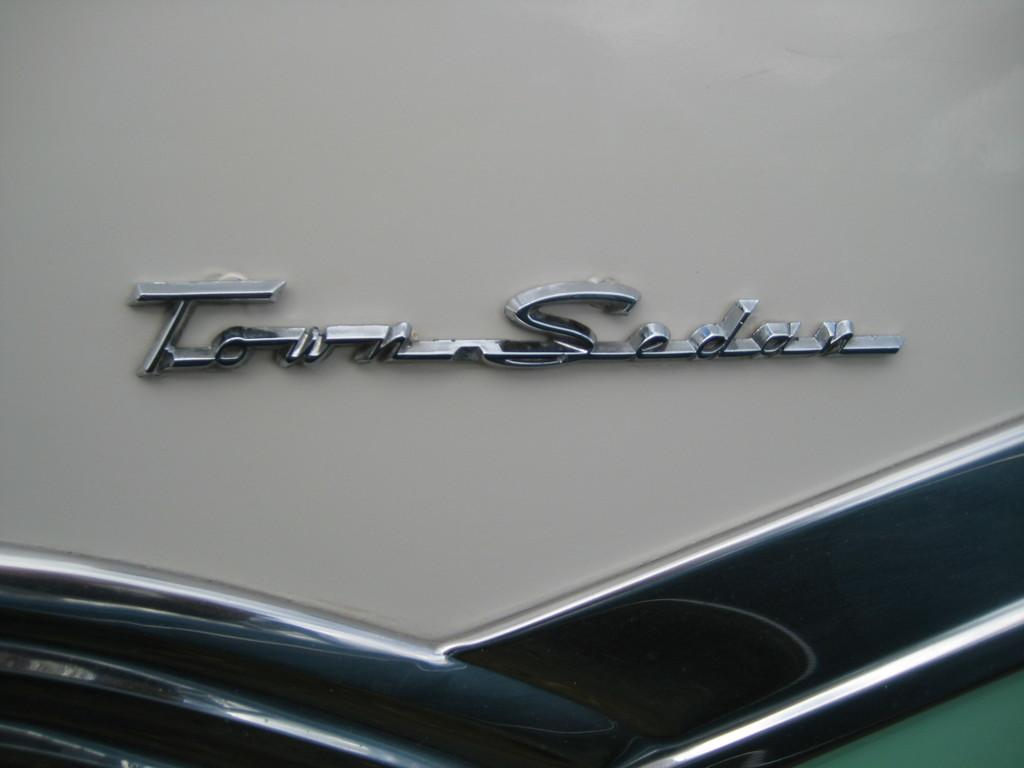What is present in the image that contains text? There is a label in the image. What type of information is on the label? The label contains the name of a car. Can you see a ghost driving the car in the image? No, there is no ghost or any indication of a ghost driving the car in the image. What season is depicted in the image? The provided facts do not mention any season or weather-related information, so it cannot be determined from the image. 